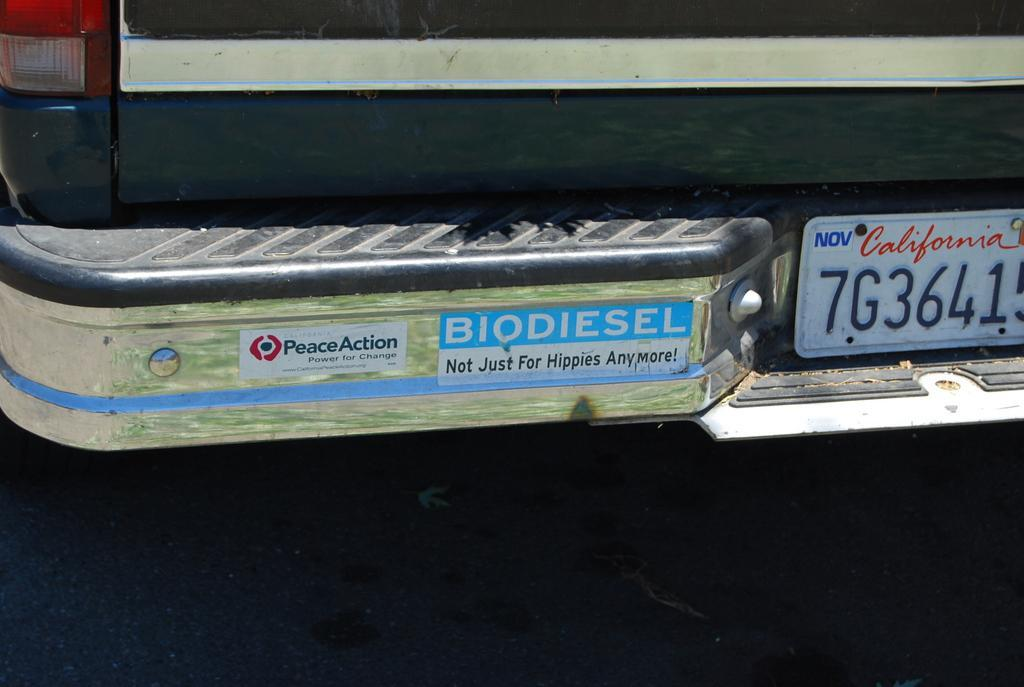<image>
Present a compact description of the photo's key features. A car with a bumper sticker saying Biodiesel not just for hippies anymore 